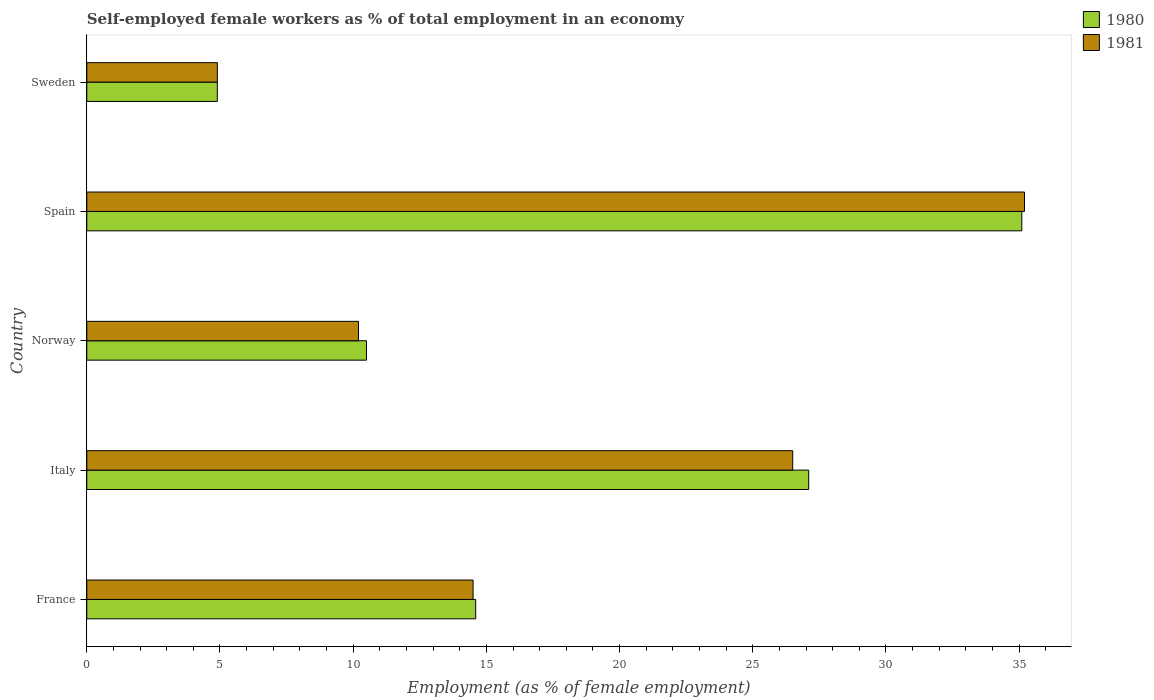How many different coloured bars are there?
Make the answer very short. 2. Are the number of bars on each tick of the Y-axis equal?
Provide a short and direct response. Yes. Across all countries, what is the maximum percentage of self-employed female workers in 1980?
Provide a short and direct response. 35.1. Across all countries, what is the minimum percentage of self-employed female workers in 1980?
Offer a terse response. 4.9. In which country was the percentage of self-employed female workers in 1981 maximum?
Your answer should be very brief. Spain. In which country was the percentage of self-employed female workers in 1981 minimum?
Keep it short and to the point. Sweden. What is the total percentage of self-employed female workers in 1980 in the graph?
Provide a short and direct response. 92.2. What is the difference between the percentage of self-employed female workers in 1981 in Italy and that in Sweden?
Your response must be concise. 21.6. What is the difference between the percentage of self-employed female workers in 1980 in Spain and the percentage of self-employed female workers in 1981 in Italy?
Offer a terse response. 8.6. What is the average percentage of self-employed female workers in 1981 per country?
Give a very brief answer. 18.26. What is the difference between the percentage of self-employed female workers in 1981 and percentage of self-employed female workers in 1980 in Italy?
Offer a terse response. -0.6. In how many countries, is the percentage of self-employed female workers in 1981 greater than 30 %?
Your response must be concise. 1. What is the ratio of the percentage of self-employed female workers in 1980 in France to that in Sweden?
Provide a succinct answer. 2.98. Is the percentage of self-employed female workers in 1980 in Spain less than that in Sweden?
Keep it short and to the point. No. Is the difference between the percentage of self-employed female workers in 1981 in Italy and Norway greater than the difference between the percentage of self-employed female workers in 1980 in Italy and Norway?
Your answer should be compact. No. What is the difference between the highest and the second highest percentage of self-employed female workers in 1981?
Offer a very short reply. 8.7. What is the difference between the highest and the lowest percentage of self-employed female workers in 1981?
Your response must be concise. 30.3. In how many countries, is the percentage of self-employed female workers in 1980 greater than the average percentage of self-employed female workers in 1980 taken over all countries?
Offer a very short reply. 2. Is the sum of the percentage of self-employed female workers in 1980 in Italy and Sweden greater than the maximum percentage of self-employed female workers in 1981 across all countries?
Provide a short and direct response. No. What does the 2nd bar from the top in France represents?
Provide a succinct answer. 1980. What is the difference between two consecutive major ticks on the X-axis?
Provide a succinct answer. 5. Does the graph contain any zero values?
Keep it short and to the point. No. How many legend labels are there?
Ensure brevity in your answer.  2. How are the legend labels stacked?
Ensure brevity in your answer.  Vertical. What is the title of the graph?
Offer a very short reply. Self-employed female workers as % of total employment in an economy. What is the label or title of the X-axis?
Offer a very short reply. Employment (as % of female employment). What is the Employment (as % of female employment) in 1980 in France?
Offer a very short reply. 14.6. What is the Employment (as % of female employment) of 1980 in Italy?
Ensure brevity in your answer.  27.1. What is the Employment (as % of female employment) of 1981 in Italy?
Ensure brevity in your answer.  26.5. What is the Employment (as % of female employment) of 1981 in Norway?
Keep it short and to the point. 10.2. What is the Employment (as % of female employment) of 1980 in Spain?
Give a very brief answer. 35.1. What is the Employment (as % of female employment) in 1981 in Spain?
Provide a succinct answer. 35.2. What is the Employment (as % of female employment) of 1980 in Sweden?
Your response must be concise. 4.9. What is the Employment (as % of female employment) in 1981 in Sweden?
Your response must be concise. 4.9. Across all countries, what is the maximum Employment (as % of female employment) of 1980?
Offer a terse response. 35.1. Across all countries, what is the maximum Employment (as % of female employment) of 1981?
Give a very brief answer. 35.2. Across all countries, what is the minimum Employment (as % of female employment) of 1980?
Keep it short and to the point. 4.9. Across all countries, what is the minimum Employment (as % of female employment) in 1981?
Ensure brevity in your answer.  4.9. What is the total Employment (as % of female employment) of 1980 in the graph?
Offer a terse response. 92.2. What is the total Employment (as % of female employment) of 1981 in the graph?
Make the answer very short. 91.3. What is the difference between the Employment (as % of female employment) of 1980 in France and that in Italy?
Provide a succinct answer. -12.5. What is the difference between the Employment (as % of female employment) in 1980 in France and that in Norway?
Provide a succinct answer. 4.1. What is the difference between the Employment (as % of female employment) of 1980 in France and that in Spain?
Offer a very short reply. -20.5. What is the difference between the Employment (as % of female employment) in 1981 in France and that in Spain?
Your answer should be very brief. -20.7. What is the difference between the Employment (as % of female employment) in 1981 in France and that in Sweden?
Provide a succinct answer. 9.6. What is the difference between the Employment (as % of female employment) of 1980 in Italy and that in Norway?
Offer a very short reply. 16.6. What is the difference between the Employment (as % of female employment) of 1981 in Italy and that in Norway?
Keep it short and to the point. 16.3. What is the difference between the Employment (as % of female employment) in 1980 in Italy and that in Spain?
Make the answer very short. -8. What is the difference between the Employment (as % of female employment) in 1981 in Italy and that in Spain?
Offer a terse response. -8.7. What is the difference between the Employment (as % of female employment) of 1980 in Italy and that in Sweden?
Your answer should be very brief. 22.2. What is the difference between the Employment (as % of female employment) in 1981 in Italy and that in Sweden?
Give a very brief answer. 21.6. What is the difference between the Employment (as % of female employment) of 1980 in Norway and that in Spain?
Your response must be concise. -24.6. What is the difference between the Employment (as % of female employment) of 1980 in Norway and that in Sweden?
Provide a short and direct response. 5.6. What is the difference between the Employment (as % of female employment) in 1980 in Spain and that in Sweden?
Provide a short and direct response. 30.2. What is the difference between the Employment (as % of female employment) in 1981 in Spain and that in Sweden?
Give a very brief answer. 30.3. What is the difference between the Employment (as % of female employment) in 1980 in France and the Employment (as % of female employment) in 1981 in Italy?
Make the answer very short. -11.9. What is the difference between the Employment (as % of female employment) in 1980 in France and the Employment (as % of female employment) in 1981 in Norway?
Keep it short and to the point. 4.4. What is the difference between the Employment (as % of female employment) in 1980 in France and the Employment (as % of female employment) in 1981 in Spain?
Provide a succinct answer. -20.6. What is the difference between the Employment (as % of female employment) in 1980 in France and the Employment (as % of female employment) in 1981 in Sweden?
Your answer should be compact. 9.7. What is the difference between the Employment (as % of female employment) in 1980 in Italy and the Employment (as % of female employment) in 1981 in Sweden?
Offer a very short reply. 22.2. What is the difference between the Employment (as % of female employment) of 1980 in Norway and the Employment (as % of female employment) of 1981 in Spain?
Your answer should be very brief. -24.7. What is the difference between the Employment (as % of female employment) in 1980 in Spain and the Employment (as % of female employment) in 1981 in Sweden?
Your answer should be compact. 30.2. What is the average Employment (as % of female employment) in 1980 per country?
Give a very brief answer. 18.44. What is the average Employment (as % of female employment) of 1981 per country?
Make the answer very short. 18.26. What is the difference between the Employment (as % of female employment) in 1980 and Employment (as % of female employment) in 1981 in Sweden?
Offer a terse response. 0. What is the ratio of the Employment (as % of female employment) of 1980 in France to that in Italy?
Offer a very short reply. 0.54. What is the ratio of the Employment (as % of female employment) in 1981 in France to that in Italy?
Offer a very short reply. 0.55. What is the ratio of the Employment (as % of female employment) of 1980 in France to that in Norway?
Your response must be concise. 1.39. What is the ratio of the Employment (as % of female employment) of 1981 in France to that in Norway?
Keep it short and to the point. 1.42. What is the ratio of the Employment (as % of female employment) in 1980 in France to that in Spain?
Your response must be concise. 0.42. What is the ratio of the Employment (as % of female employment) of 1981 in France to that in Spain?
Provide a short and direct response. 0.41. What is the ratio of the Employment (as % of female employment) of 1980 in France to that in Sweden?
Keep it short and to the point. 2.98. What is the ratio of the Employment (as % of female employment) of 1981 in France to that in Sweden?
Make the answer very short. 2.96. What is the ratio of the Employment (as % of female employment) in 1980 in Italy to that in Norway?
Your answer should be compact. 2.58. What is the ratio of the Employment (as % of female employment) of 1981 in Italy to that in Norway?
Your answer should be compact. 2.6. What is the ratio of the Employment (as % of female employment) in 1980 in Italy to that in Spain?
Your answer should be compact. 0.77. What is the ratio of the Employment (as % of female employment) in 1981 in Italy to that in Spain?
Give a very brief answer. 0.75. What is the ratio of the Employment (as % of female employment) of 1980 in Italy to that in Sweden?
Provide a succinct answer. 5.53. What is the ratio of the Employment (as % of female employment) of 1981 in Italy to that in Sweden?
Offer a terse response. 5.41. What is the ratio of the Employment (as % of female employment) in 1980 in Norway to that in Spain?
Your response must be concise. 0.3. What is the ratio of the Employment (as % of female employment) in 1981 in Norway to that in Spain?
Ensure brevity in your answer.  0.29. What is the ratio of the Employment (as % of female employment) of 1980 in Norway to that in Sweden?
Offer a terse response. 2.14. What is the ratio of the Employment (as % of female employment) of 1981 in Norway to that in Sweden?
Provide a short and direct response. 2.08. What is the ratio of the Employment (as % of female employment) of 1980 in Spain to that in Sweden?
Your answer should be very brief. 7.16. What is the ratio of the Employment (as % of female employment) of 1981 in Spain to that in Sweden?
Ensure brevity in your answer.  7.18. What is the difference between the highest and the lowest Employment (as % of female employment) of 1980?
Provide a short and direct response. 30.2. What is the difference between the highest and the lowest Employment (as % of female employment) of 1981?
Provide a succinct answer. 30.3. 